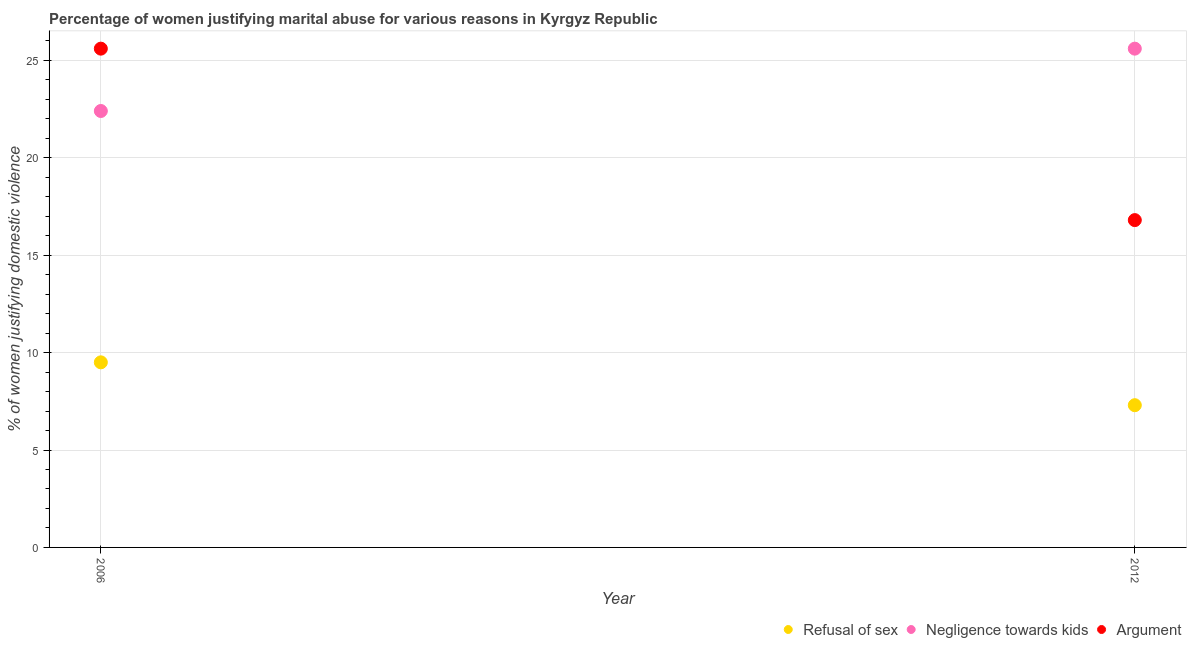How many different coloured dotlines are there?
Give a very brief answer. 3. What is the percentage of women justifying domestic violence due to negligence towards kids in 2006?
Offer a terse response. 22.4. Across all years, what is the maximum percentage of women justifying domestic violence due to negligence towards kids?
Keep it short and to the point. 25.6. Across all years, what is the minimum percentage of women justifying domestic violence due to negligence towards kids?
Provide a succinct answer. 22.4. What is the difference between the percentage of women justifying domestic violence due to negligence towards kids in 2006 and that in 2012?
Ensure brevity in your answer.  -3.2. What is the average percentage of women justifying domestic violence due to arguments per year?
Provide a short and direct response. 21.2. In the year 2006, what is the difference between the percentage of women justifying domestic violence due to negligence towards kids and percentage of women justifying domestic violence due to arguments?
Provide a succinct answer. -3.2. In how many years, is the percentage of women justifying domestic violence due to negligence towards kids greater than 24 %?
Provide a succinct answer. 1. What is the ratio of the percentage of women justifying domestic violence due to refusal of sex in 2006 to that in 2012?
Keep it short and to the point. 1.3. In how many years, is the percentage of women justifying domestic violence due to negligence towards kids greater than the average percentage of women justifying domestic violence due to negligence towards kids taken over all years?
Your answer should be very brief. 1. Is the percentage of women justifying domestic violence due to refusal of sex strictly greater than the percentage of women justifying domestic violence due to negligence towards kids over the years?
Provide a succinct answer. No. Are the values on the major ticks of Y-axis written in scientific E-notation?
Your response must be concise. No. Does the graph contain any zero values?
Provide a succinct answer. No. Does the graph contain grids?
Your response must be concise. Yes. Where does the legend appear in the graph?
Give a very brief answer. Bottom right. What is the title of the graph?
Keep it short and to the point. Percentage of women justifying marital abuse for various reasons in Kyrgyz Republic. Does "Coal sources" appear as one of the legend labels in the graph?
Make the answer very short. No. What is the label or title of the X-axis?
Make the answer very short. Year. What is the label or title of the Y-axis?
Offer a very short reply. % of women justifying domestic violence. What is the % of women justifying domestic violence in Negligence towards kids in 2006?
Provide a succinct answer. 22.4. What is the % of women justifying domestic violence in Argument in 2006?
Offer a very short reply. 25.6. What is the % of women justifying domestic violence of Refusal of sex in 2012?
Your answer should be very brief. 7.3. What is the % of women justifying domestic violence of Negligence towards kids in 2012?
Offer a very short reply. 25.6. What is the % of women justifying domestic violence in Argument in 2012?
Your answer should be very brief. 16.8. Across all years, what is the maximum % of women justifying domestic violence in Refusal of sex?
Your answer should be very brief. 9.5. Across all years, what is the maximum % of women justifying domestic violence of Negligence towards kids?
Your answer should be very brief. 25.6. Across all years, what is the maximum % of women justifying domestic violence in Argument?
Ensure brevity in your answer.  25.6. Across all years, what is the minimum % of women justifying domestic violence in Refusal of sex?
Give a very brief answer. 7.3. Across all years, what is the minimum % of women justifying domestic violence in Negligence towards kids?
Give a very brief answer. 22.4. Across all years, what is the minimum % of women justifying domestic violence of Argument?
Your answer should be very brief. 16.8. What is the total % of women justifying domestic violence of Negligence towards kids in the graph?
Your response must be concise. 48. What is the total % of women justifying domestic violence of Argument in the graph?
Ensure brevity in your answer.  42.4. What is the difference between the % of women justifying domestic violence of Refusal of sex in 2006 and that in 2012?
Your answer should be very brief. 2.2. What is the difference between the % of women justifying domestic violence in Negligence towards kids in 2006 and that in 2012?
Offer a very short reply. -3.2. What is the difference between the % of women justifying domestic violence of Argument in 2006 and that in 2012?
Your response must be concise. 8.8. What is the difference between the % of women justifying domestic violence of Refusal of sex in 2006 and the % of women justifying domestic violence of Negligence towards kids in 2012?
Your answer should be very brief. -16.1. What is the average % of women justifying domestic violence of Refusal of sex per year?
Keep it short and to the point. 8.4. What is the average % of women justifying domestic violence of Argument per year?
Your answer should be compact. 21.2. In the year 2006, what is the difference between the % of women justifying domestic violence in Refusal of sex and % of women justifying domestic violence in Argument?
Your answer should be very brief. -16.1. In the year 2012, what is the difference between the % of women justifying domestic violence of Refusal of sex and % of women justifying domestic violence of Negligence towards kids?
Give a very brief answer. -18.3. In the year 2012, what is the difference between the % of women justifying domestic violence of Refusal of sex and % of women justifying domestic violence of Argument?
Offer a very short reply. -9.5. What is the ratio of the % of women justifying domestic violence in Refusal of sex in 2006 to that in 2012?
Provide a succinct answer. 1.3. What is the ratio of the % of women justifying domestic violence of Negligence towards kids in 2006 to that in 2012?
Your response must be concise. 0.88. What is the ratio of the % of women justifying domestic violence of Argument in 2006 to that in 2012?
Make the answer very short. 1.52. What is the difference between the highest and the second highest % of women justifying domestic violence of Refusal of sex?
Offer a terse response. 2.2. What is the difference between the highest and the second highest % of women justifying domestic violence in Negligence towards kids?
Ensure brevity in your answer.  3.2. What is the difference between the highest and the lowest % of women justifying domestic violence in Refusal of sex?
Make the answer very short. 2.2. What is the difference between the highest and the lowest % of women justifying domestic violence of Negligence towards kids?
Give a very brief answer. 3.2. 